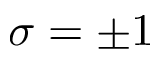Convert formula to latex. <formula><loc_0><loc_0><loc_500><loc_500>\sigma = \pm 1</formula> 